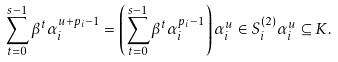Convert formula to latex. <formula><loc_0><loc_0><loc_500><loc_500>\sum _ { t = 0 } ^ { s - 1 } \beta ^ { t } \alpha _ { i } ^ { u + p _ { i } - 1 } = \left ( \sum _ { t = 0 } ^ { s - 1 } \beta ^ { t } \alpha _ { i } ^ { p _ { i } - 1 } \right ) \alpha _ { i } ^ { u } \in S _ { i } ^ { ( 2 ) } \alpha _ { i } ^ { u } \subseteq K .</formula> 